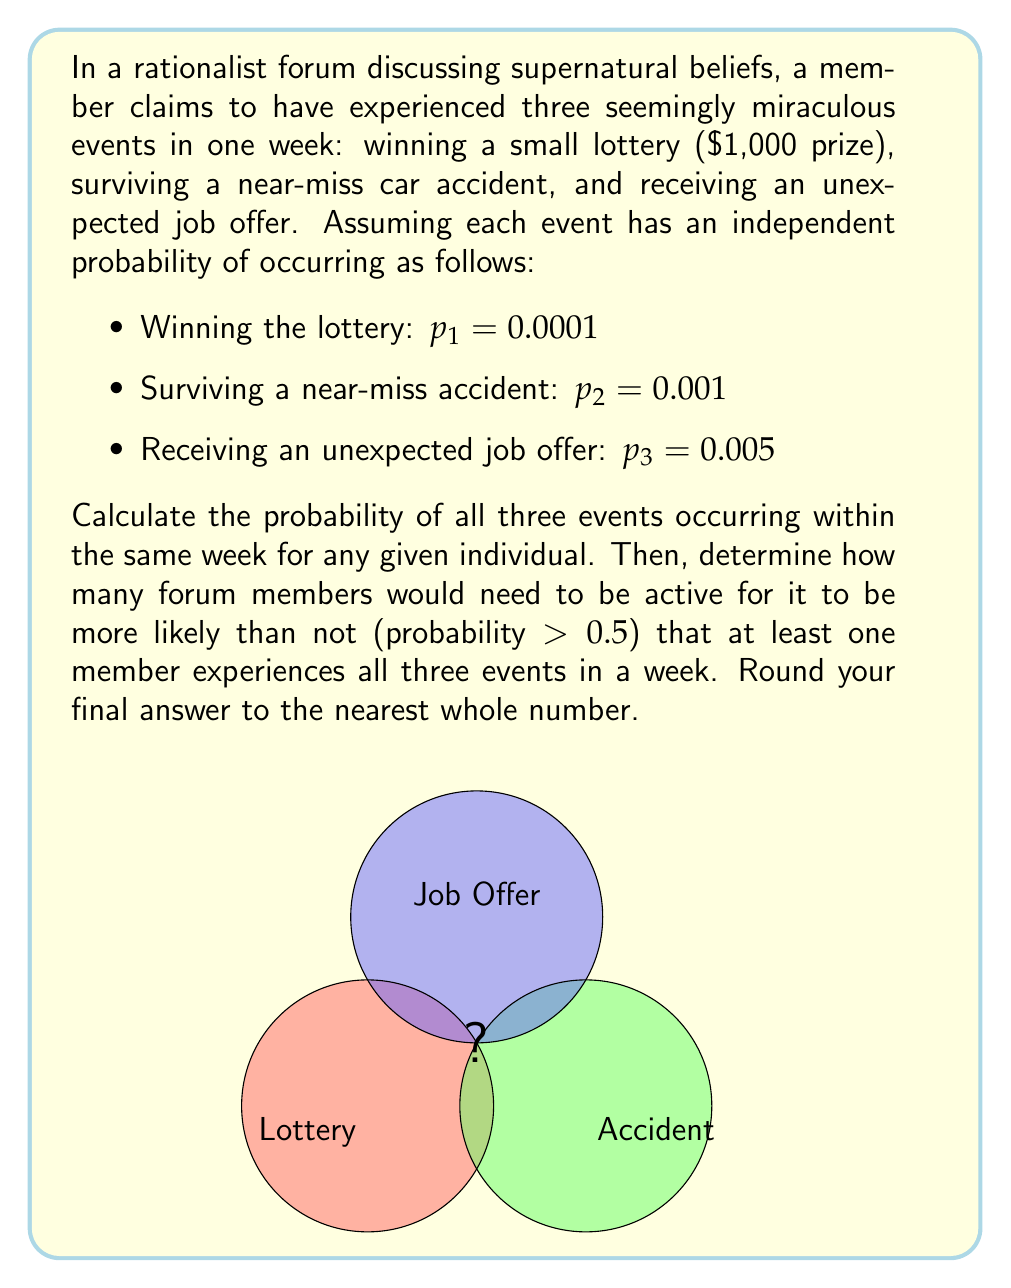Can you solve this math problem? Let's approach this step-by-step:

1) First, we need to calculate the probability of all three events occurring in the same week for one individual.

   Since the events are independent, we multiply their individual probabilities:

   $$P(\text{all three events}) = p_1 \cdot p_2 \cdot p_3 = 0.0001 \cdot 0.001 \cdot 0.005 = 5 \times 10^{-10}$$

2) Now, we need to find how many forum members (let's call this number $n$) are needed for the probability of at least one member experiencing all three events to be greater than 0.5.

3) The probability of at least one member experiencing all three events is the complement of no members experiencing all three events:

   $$P(\text{at least one}) = 1 - P(\text{none})$$

4) The probability of no members experiencing all three events is:

   $$P(\text{none}) = (1 - 5 \times 10^{-10})^n$$

5) We want this probability to be less than 0.5:

   $$1 - (1 - 5 \times 10^{-10})^n > 0.5$$

6) Solving for $n$:

   $$(1 - 5 \times 10^{-10})^n < 0.5$$
   
   $$n \cdot \log(1 - 5 \times 10^{-10}) < \log(0.5)$$
   
   $$n > \frac{\log(0.5)}{\log(1 - 5 \times 10^{-10})} \approx 1,386,294,361$$

7) Rounding up to the nearest whole number:

   $$n = 1,386,294,361$$

Therefore, you would need 1,386,294,361 forum members for it to be more likely than not that at least one experiences all three events in a week.
Answer: 1,386,294,361 members 